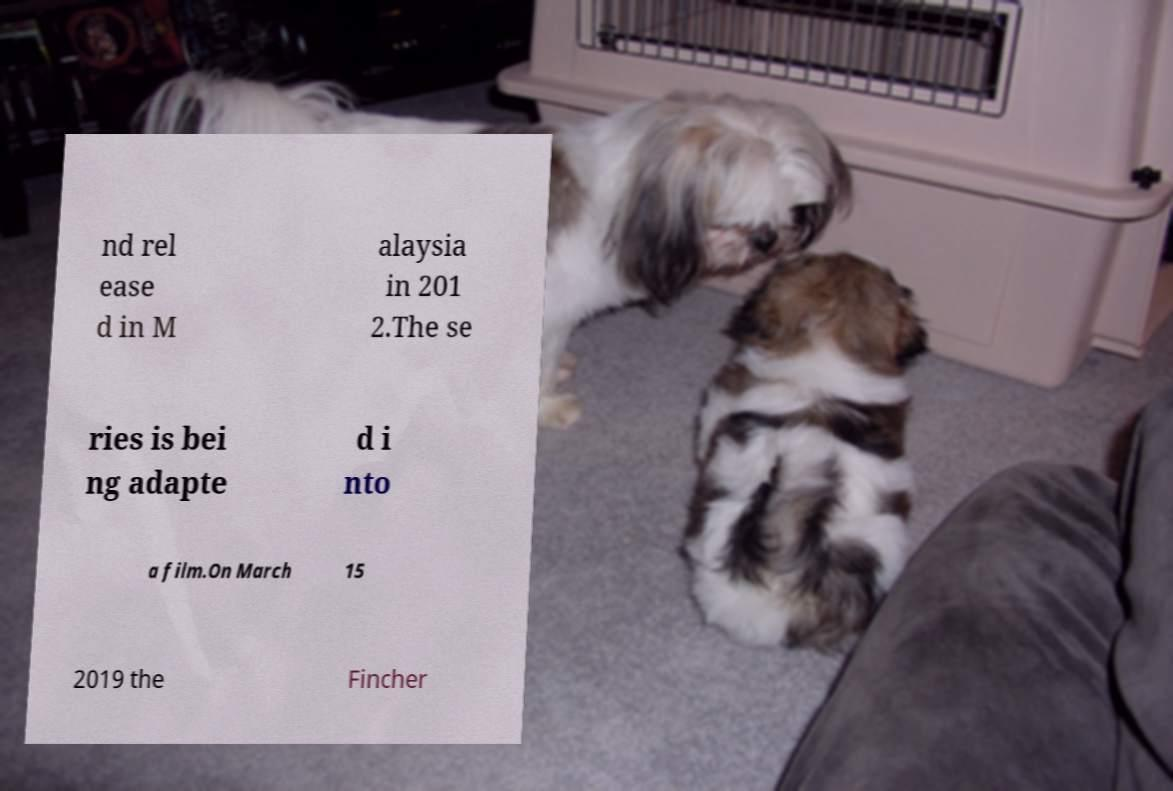Could you assist in decoding the text presented in this image and type it out clearly? nd rel ease d in M alaysia in 201 2.The se ries is bei ng adapte d i nto a film.On March 15 2019 the Fincher 